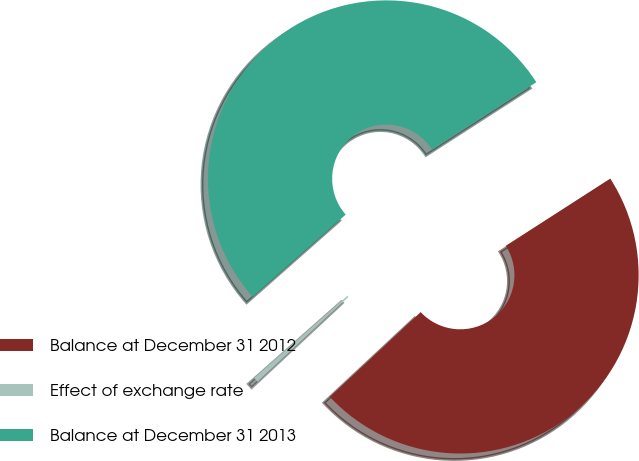<chart> <loc_0><loc_0><loc_500><loc_500><pie_chart><fcel>Balance at December 31 2012<fcel>Effect of exchange rate<fcel>Balance at December 31 2013<nl><fcel>47.15%<fcel>0.44%<fcel>52.41%<nl></chart> 